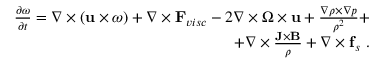<formula> <loc_0><loc_0><loc_500><loc_500>\begin{array} { r } { \frac { \partial \omega } { \partial t } = \nabla \times ( u \times \omega ) + \nabla \times F _ { v i s c } - 2 \nabla \times \Omega \times u + \frac { \nabla \rho \times \nabla p } { \rho ^ { 2 } } + } \\ { + \nabla \times \frac { J \times B } { \rho } + \nabla \times f _ { s } . } \end{array}</formula> 